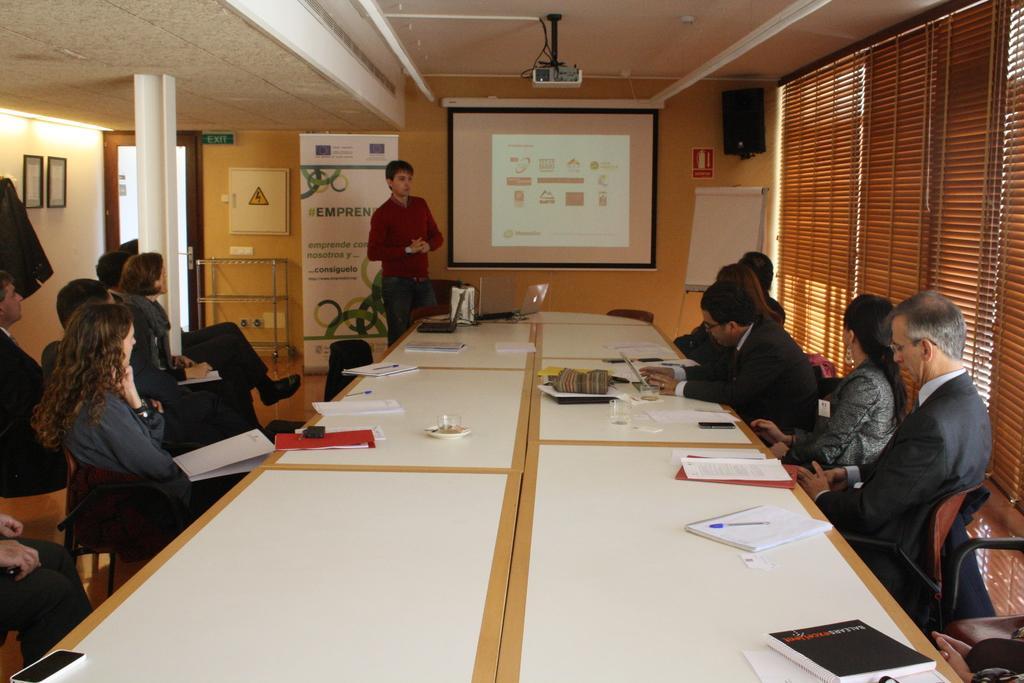Could you give a brief overview of what you see in this image? In this image I see number of people in which most of them are sitting on chairs and this man is standing over here. I can also see there are tables in front of them on which there are papers, books, laptops and other things. In the background I see the board on which there are papers, a projector screen, projector over here, door, lights over here, photo frame on the wall and a speaker. 